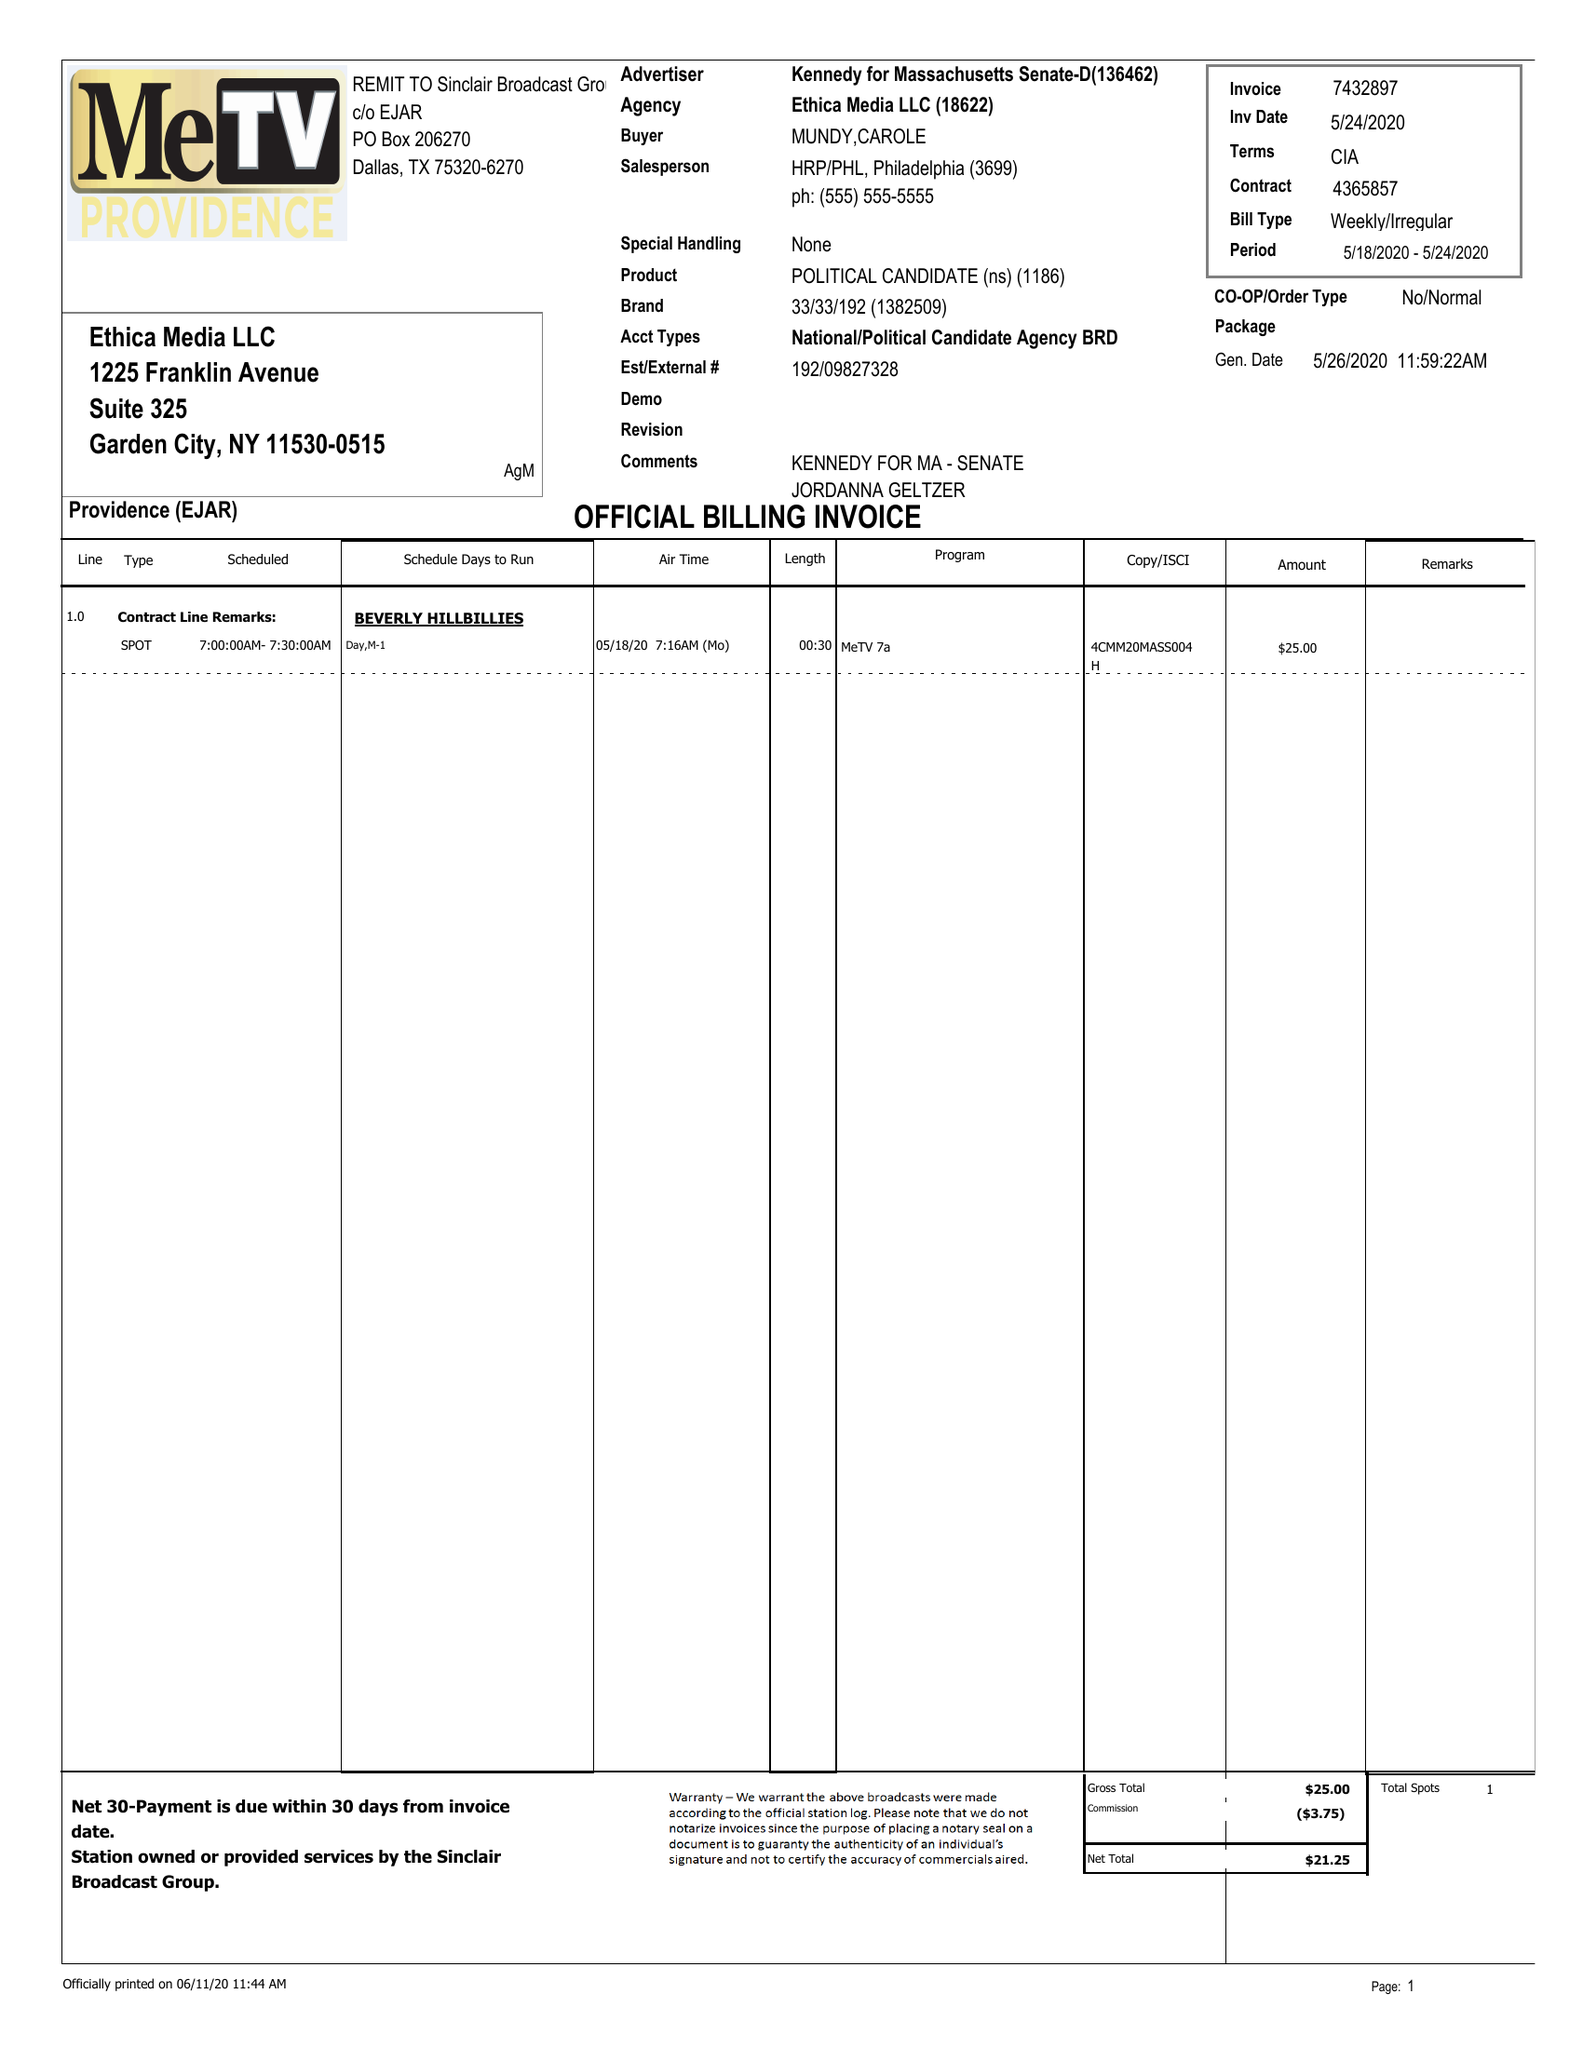What is the value for the flight_from?
Answer the question using a single word or phrase. 05/18/20 